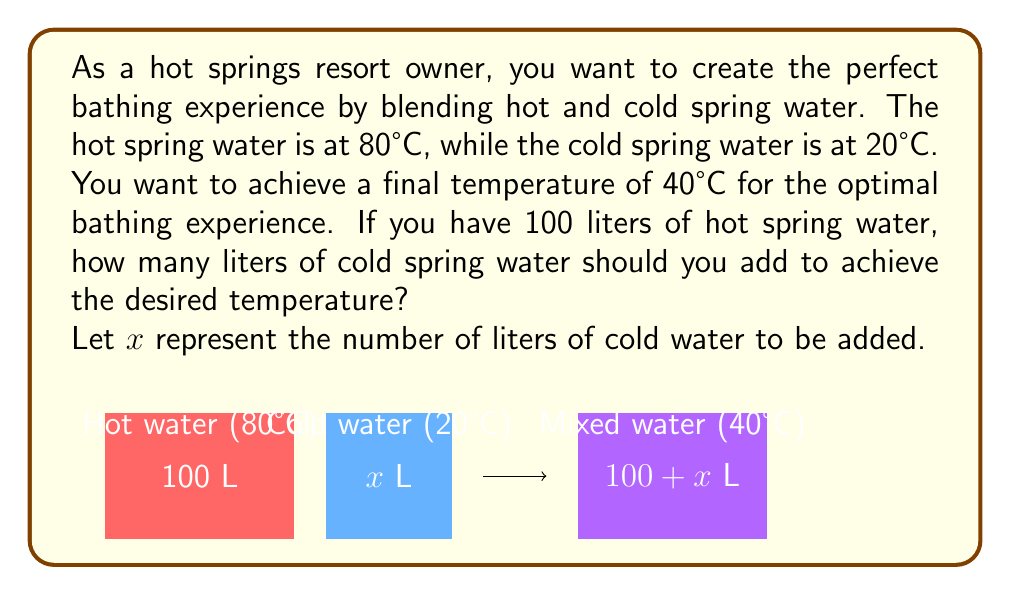Show me your answer to this math problem. Let's approach this step-by-step using the concept of weighted averages:

1) The total volume after mixing will be $100 + x$ liters.

2) We can set up an equation based on the principle that the total heat content before mixing equals the total heat content after mixing:

   $$(100 \cdot 80) + (x \cdot 20) = (100 + x) \cdot 40$$

3) Let's simplify the left side of the equation:
   $$8000 + 20x = (100 + x) \cdot 40$$

4) Expand the right side:
   $$8000 + 20x = 4000 + 40x$$

5) Subtract 4000 from both sides:
   $$4000 + 20x = 40x$$

6) Subtract 20x from both sides:
   $$4000 = 20x$$

7) Divide both sides by 20:
   $$200 = x$$

Therefore, you need to add 200 liters of cold water to 100 liters of hot water to achieve the desired temperature of 40°C.

To verify:
- Total volume: $100 + 200 = 300$ liters
- Heat content: $(100 \cdot 80) + (200 \cdot 20) = 8000 + 4000 = 12000$
- Average temperature: $12000 \div 300 = 40°C$
Answer: 200 liters 